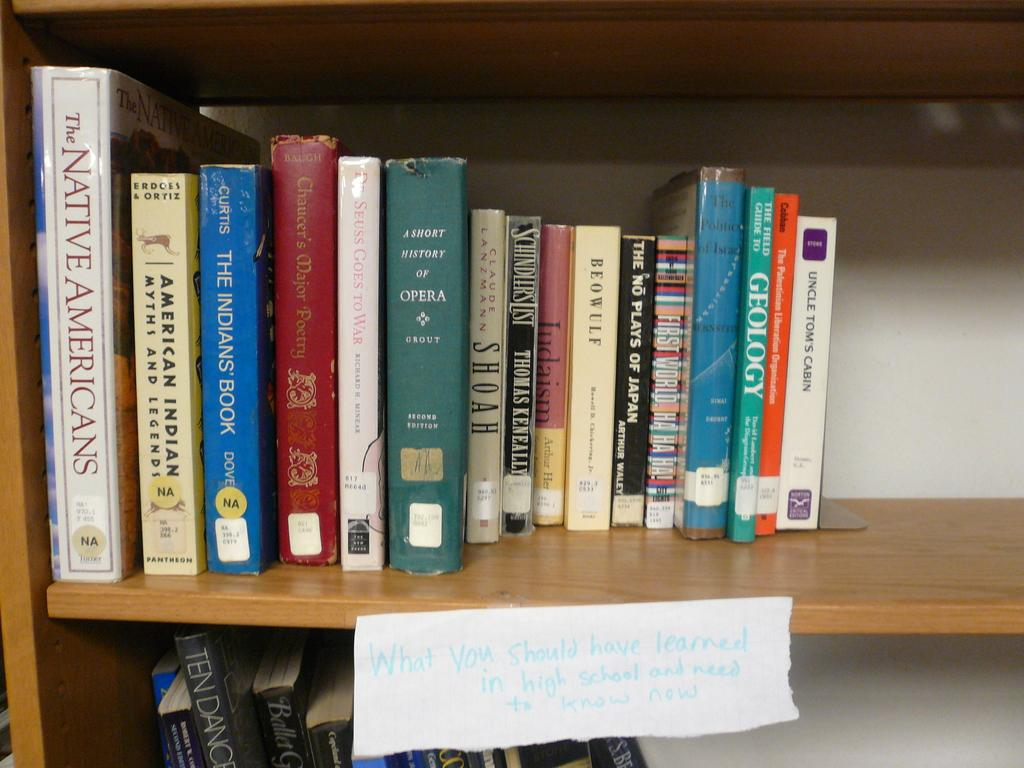<image>
Render a clear and concise summary of the photo. a row of books include The Native Americans and Geology 